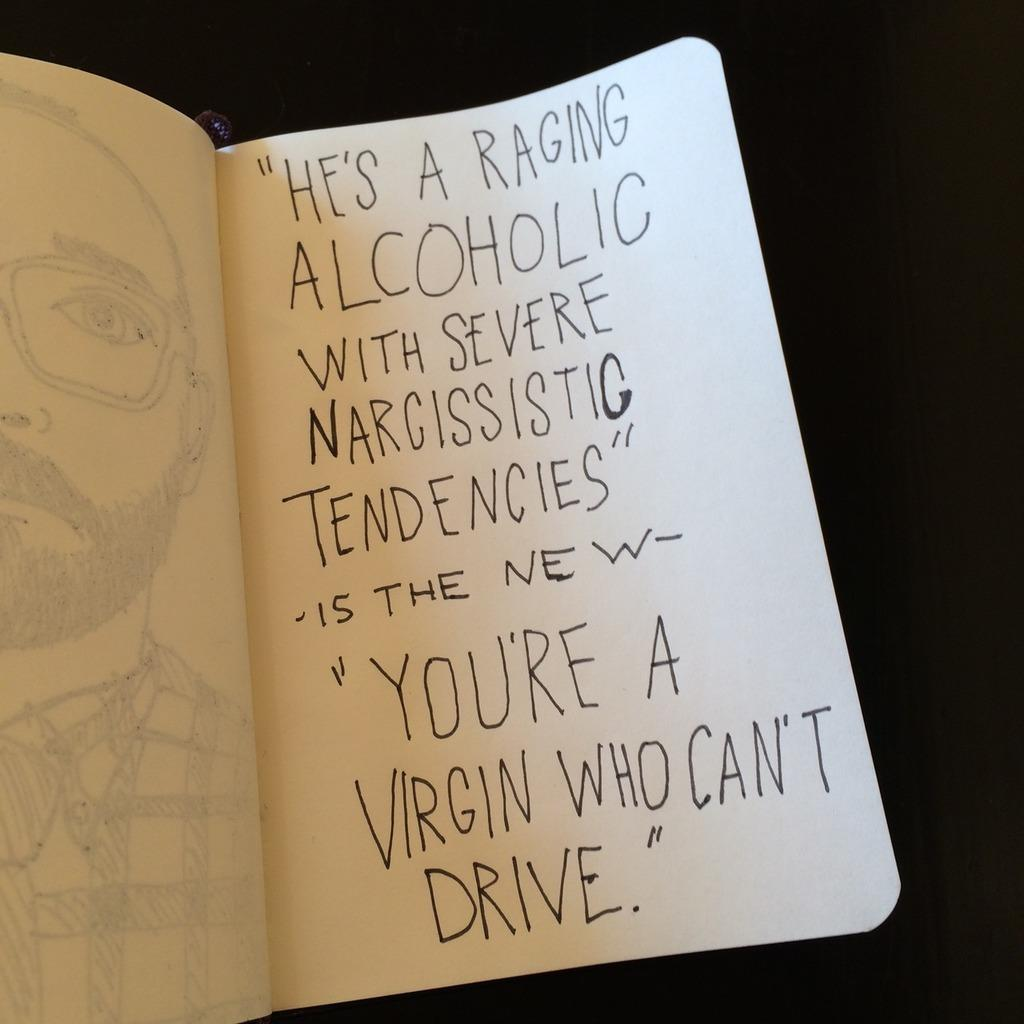Provide a one-sentence caption for the provided image. A hand written message which ends with the words 'a virgin who can't drive'. 